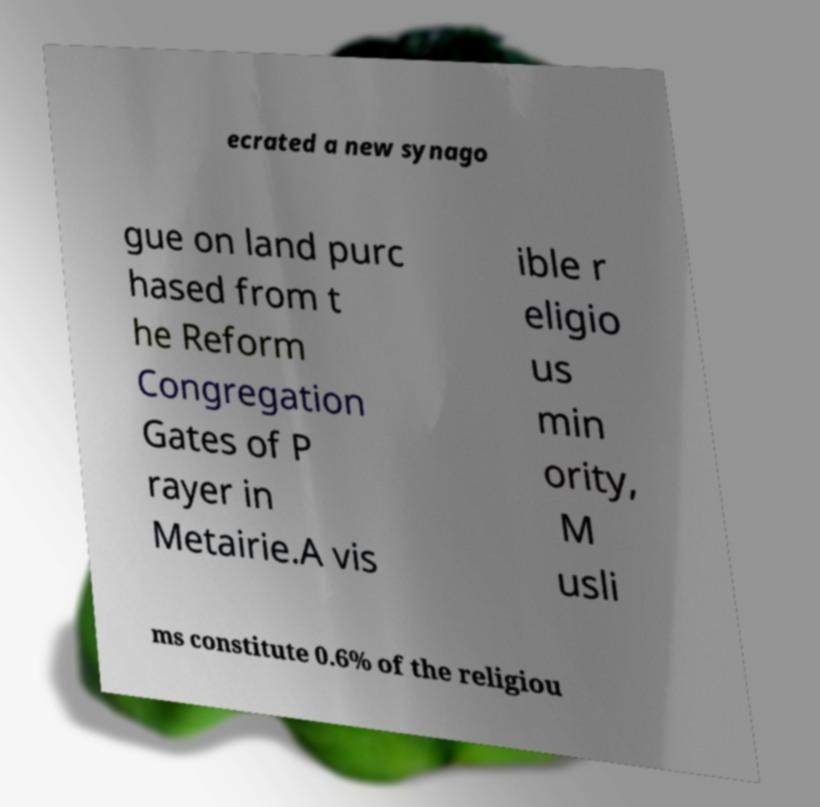Please identify and transcribe the text found in this image. ecrated a new synago gue on land purc hased from t he Reform Congregation Gates of P rayer in Metairie.A vis ible r eligio us min ority, M usli ms constitute 0.6% of the religiou 